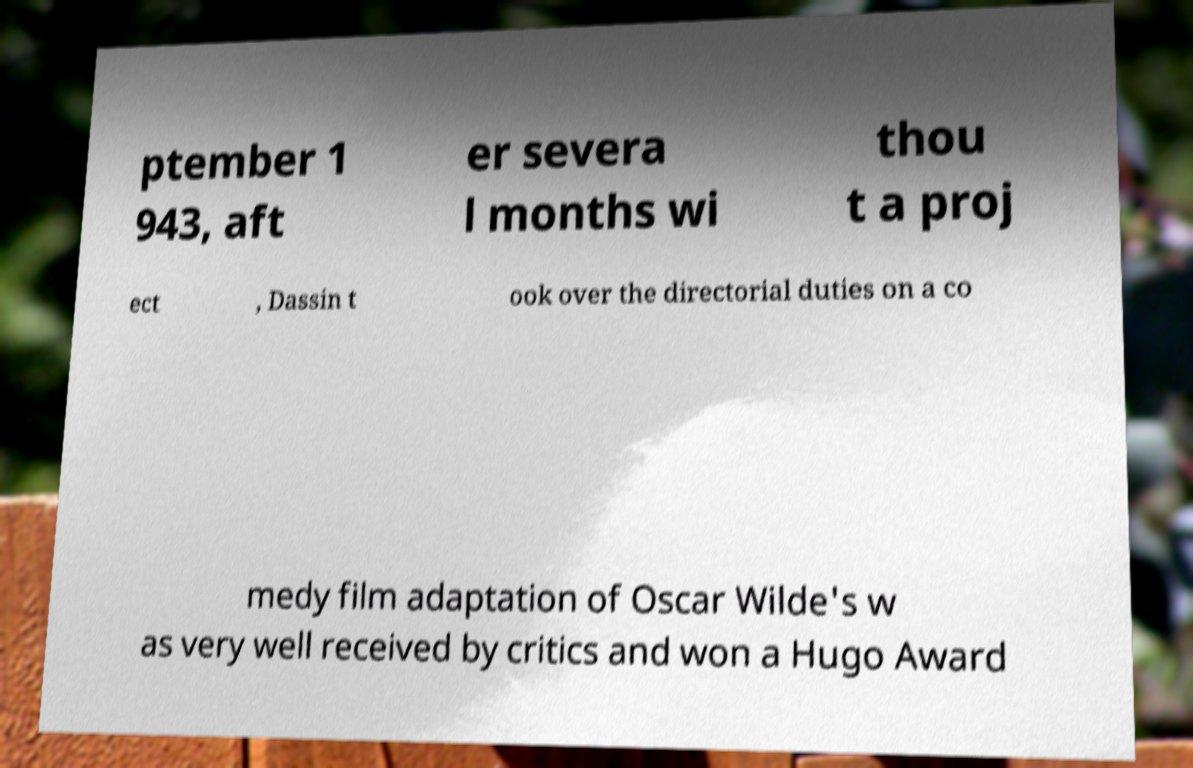Please read and relay the text visible in this image. What does it say? ptember 1 943, aft er severa l months wi thou t a proj ect , Dassin t ook over the directorial duties on a co medy film adaptation of Oscar Wilde's w as very well received by critics and won a Hugo Award 